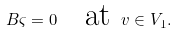Convert formula to latex. <formula><loc_0><loc_0><loc_500><loc_500>B \varsigma = 0 \text { \ \ at } v \in V _ { 1 } .</formula> 